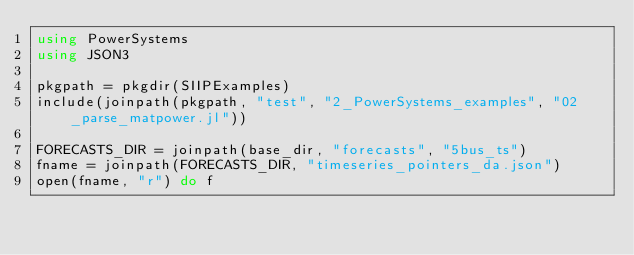<code> <loc_0><loc_0><loc_500><loc_500><_Julia_>using PowerSystems
using JSON3

pkgpath = pkgdir(SIIPExamples)
include(joinpath(pkgpath, "test", "2_PowerSystems_examples", "02_parse_matpower.jl"))

FORECASTS_DIR = joinpath(base_dir, "forecasts", "5bus_ts")
fname = joinpath(FORECASTS_DIR, "timeseries_pointers_da.json")
open(fname, "r") do f</code> 